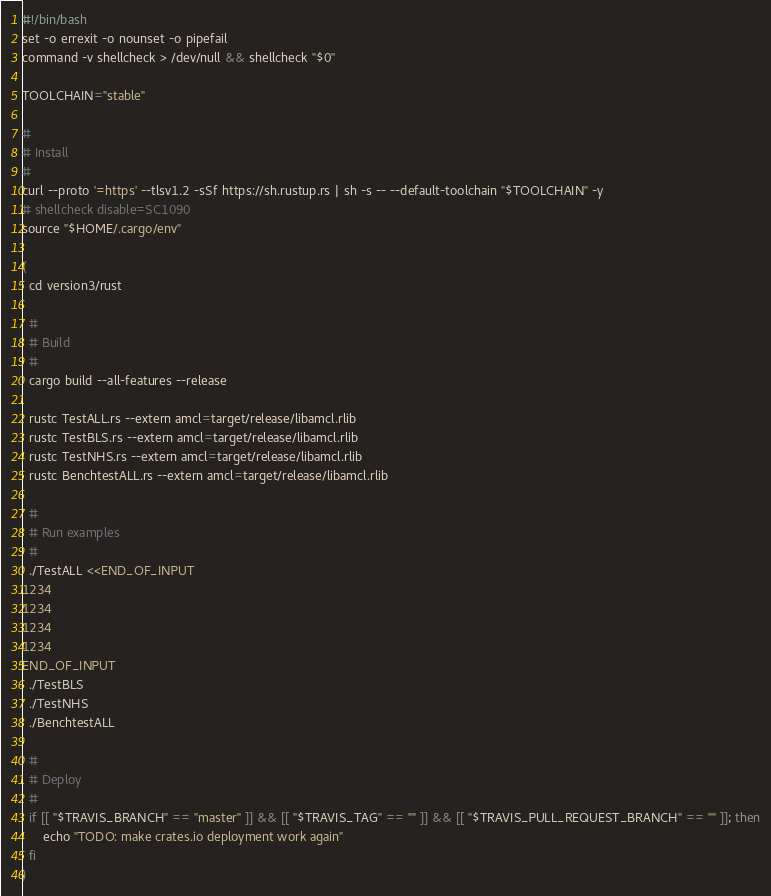Convert code to text. <code><loc_0><loc_0><loc_500><loc_500><_Bash_>#!/bin/bash
set -o errexit -o nounset -o pipefail
command -v shellcheck > /dev/null && shellcheck "$0"

TOOLCHAIN="stable"

#
# Install
#
curl --proto '=https' --tlsv1.2 -sSf https://sh.rustup.rs | sh -s -- --default-toolchain "$TOOLCHAIN" -y
# shellcheck disable=SC1090
source "$HOME/.cargo/env"

(
  cd version3/rust

  #
  # Build
  #
  cargo build --all-features --release

  rustc TestALL.rs --extern amcl=target/release/libamcl.rlib
  rustc TestBLS.rs --extern amcl=target/release/libamcl.rlib
  rustc TestNHS.rs --extern amcl=target/release/libamcl.rlib
  rustc BenchtestALL.rs --extern amcl=target/release/libamcl.rlib

  #
  # Run examples
  #
  ./TestALL <<END_OF_INPUT
1234
1234
1234
1234
END_OF_INPUT
  ./TestBLS
  ./TestNHS
  ./BenchtestALL

  #
  # Deploy
  #
  if [[ "$TRAVIS_BRANCH" == "master" ]] && [[ "$TRAVIS_TAG" == "" ]] && [[ "$TRAVIS_PULL_REQUEST_BRANCH" == "" ]]; then
      echo "TODO: make crates.io deployment work again"
  fi
)
</code> 